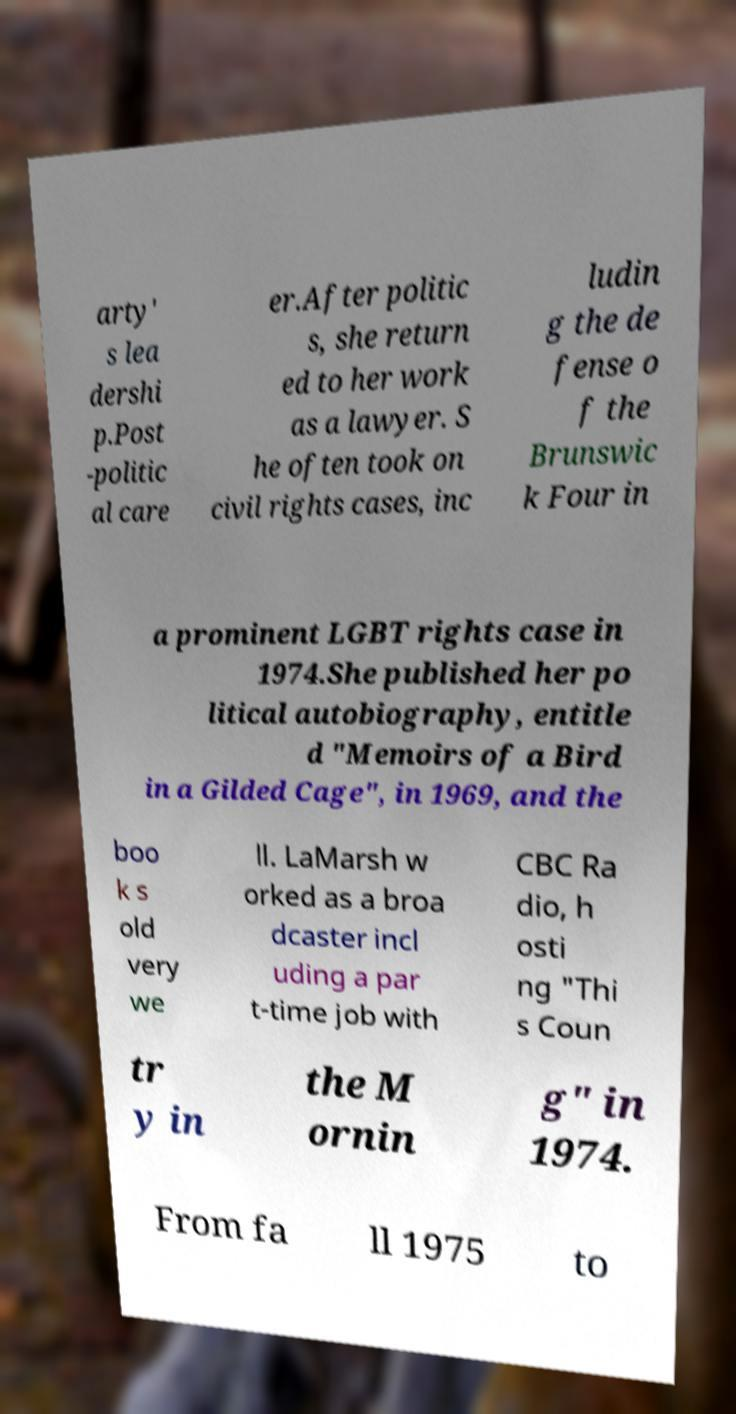What messages or text are displayed in this image? I need them in a readable, typed format. arty' s lea dershi p.Post -politic al care er.After politic s, she return ed to her work as a lawyer. S he often took on civil rights cases, inc ludin g the de fense o f the Brunswic k Four in a prominent LGBT rights case in 1974.She published her po litical autobiography, entitle d "Memoirs of a Bird in a Gilded Cage", in 1969, and the boo k s old very we ll. LaMarsh w orked as a broa dcaster incl uding a par t-time job with CBC Ra dio, h osti ng "Thi s Coun tr y in the M ornin g" in 1974. From fa ll 1975 to 